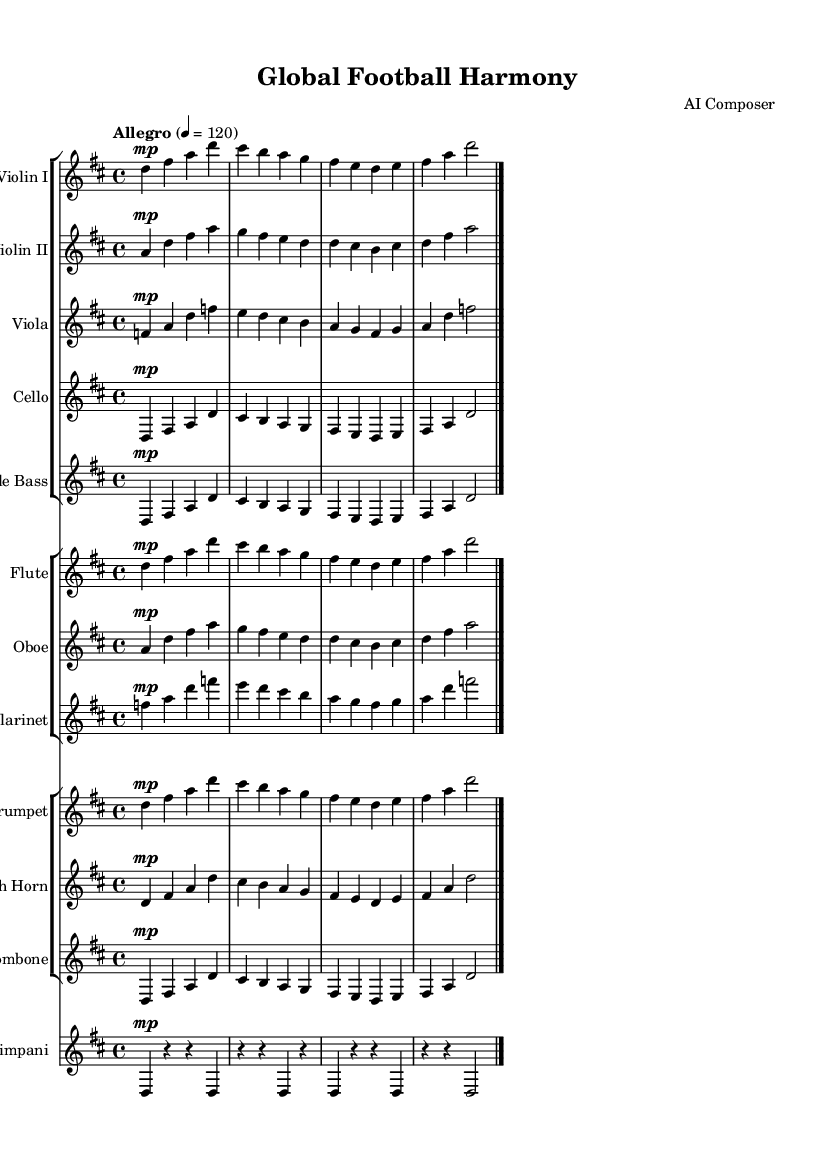What is the key signature of this symphony? The key signature is D major, which contains two sharps (F# and C#). This is indicated at the beginning of the staff where the sharps are placed.
Answer: D major What is the time signature of this piece? The time signature is 4/4, which indicates there are four beats in a measure and the quarter note gets one beat. This information is shown at the beginning of the score.
Answer: 4/4 What is the tempo marking for this symphony? The tempo marking is "Allegro," which indicates a lively and fast tempo, as noted at the start of the score style.
Answer: Allegro Which instruments are in the first group? The first group consists of Violin I, Violin II, Viola, Cello, and Double Bass. This is indicated by the staff groups presented in the score.
Answer: Violin I, Violin II, Viola, Cello, Double Bass How many measures are present in the given music for each instrument? Each instrument has a total of four measures displayed in the example, as observed by counting the bars separated by vertical lines in the musical notation.
Answer: Four Which instrument plays a part that includes the notes F, A, and D? The Viola plays a part that prominently features the notes F, A, and D, as indicated within its specific measure of music notation.
Answer: Viola What is the dynamic indication for all parts in this symphony? The dynamic indication for all parts is marked as "mp," which stands for mezzo-piano, indicating a moderately soft dynamic level across all instruments.
Answer: Mezzo-piano 